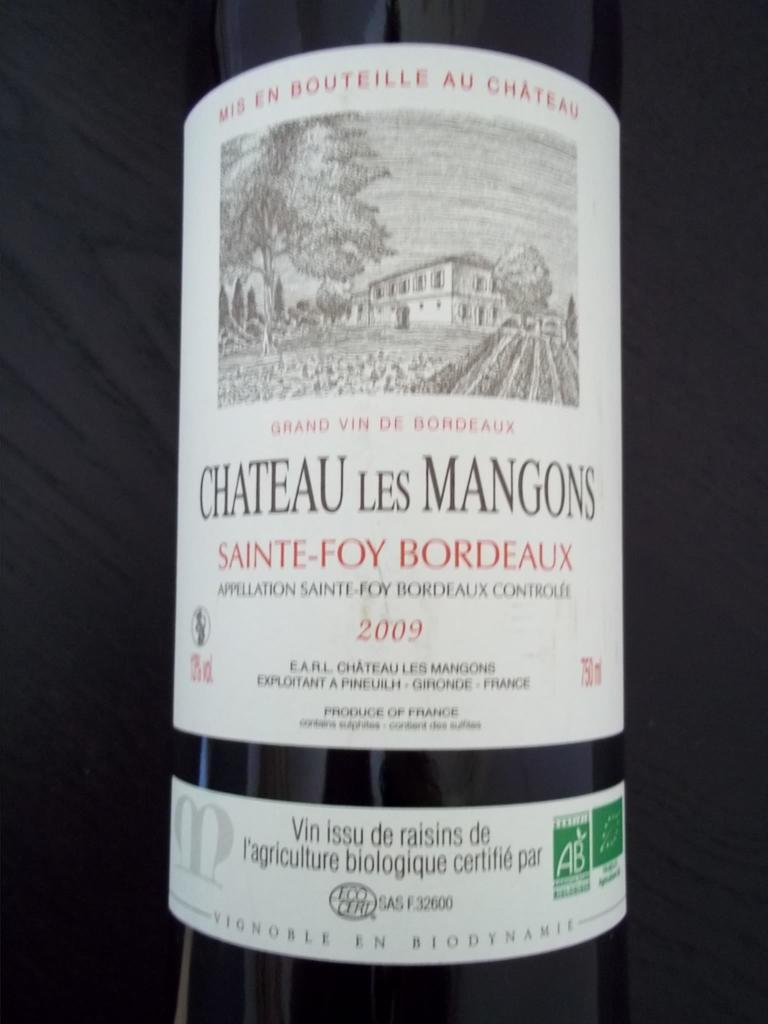<image>
Describe the image concisely. A bottle from 2009 of Chateau Les Mangons. 